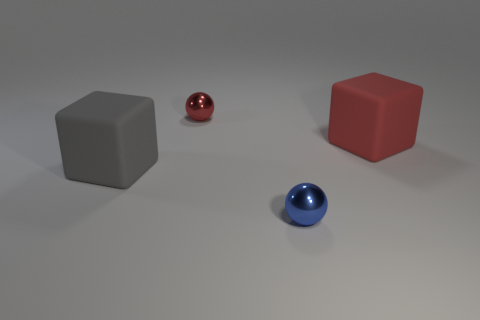Add 1 blue shiny things. How many objects exist? 5 Subtract 1 gray cubes. How many objects are left? 3 Subtract all large red cubes. Subtract all tiny blue objects. How many objects are left? 2 Add 2 big rubber things. How many big rubber things are left? 4 Add 3 tiny red metal objects. How many tiny red metal objects exist? 4 